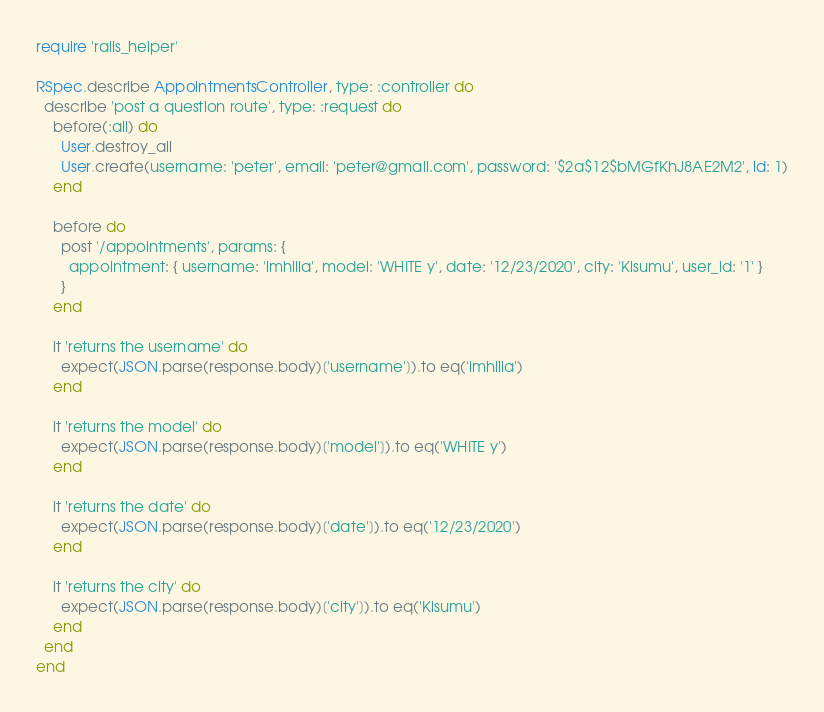Convert code to text. <code><loc_0><loc_0><loc_500><loc_500><_Ruby_>require 'rails_helper'

RSpec.describe AppointmentsController, type: :controller do
  describe 'post a question route', type: :request do
    before(:all) do
      User.destroy_all
      User.create(username: 'peter', email: 'peter@gmail.com', password: '$2a$12$bMGfKhJ8AE2M2', id: 1)
    end

    before do
      post '/appointments', params: {
        appointment: { username: 'imhilla', model: 'WHITE y', date: '12/23/2020', city: 'Kisumu', user_id: '1' }
      }
    end

    it 'returns the username' do
      expect(JSON.parse(response.body)['username']).to eq('imhilla')
    end

    it 'returns the model' do
      expect(JSON.parse(response.body)['model']).to eq('WHITE y')
    end

    it 'returns the date' do
      expect(JSON.parse(response.body)['date']).to eq('12/23/2020')
    end

    it 'returns the city' do
      expect(JSON.parse(response.body)['city']).to eq('Kisumu')
    end
  end
end
</code> 